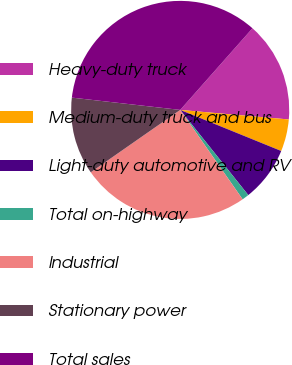Convert chart to OTSL. <chart><loc_0><loc_0><loc_500><loc_500><pie_chart><fcel>Heavy-duty truck<fcel>Medium-duty truck and bus<fcel>Light-duty automotive and RV<fcel>Total on-highway<fcel>Industrial<fcel>Stationary power<fcel>Total sales<nl><fcel>14.86%<fcel>4.75%<fcel>8.12%<fcel>1.03%<fcel>25.01%<fcel>11.49%<fcel>34.73%<nl></chart> 